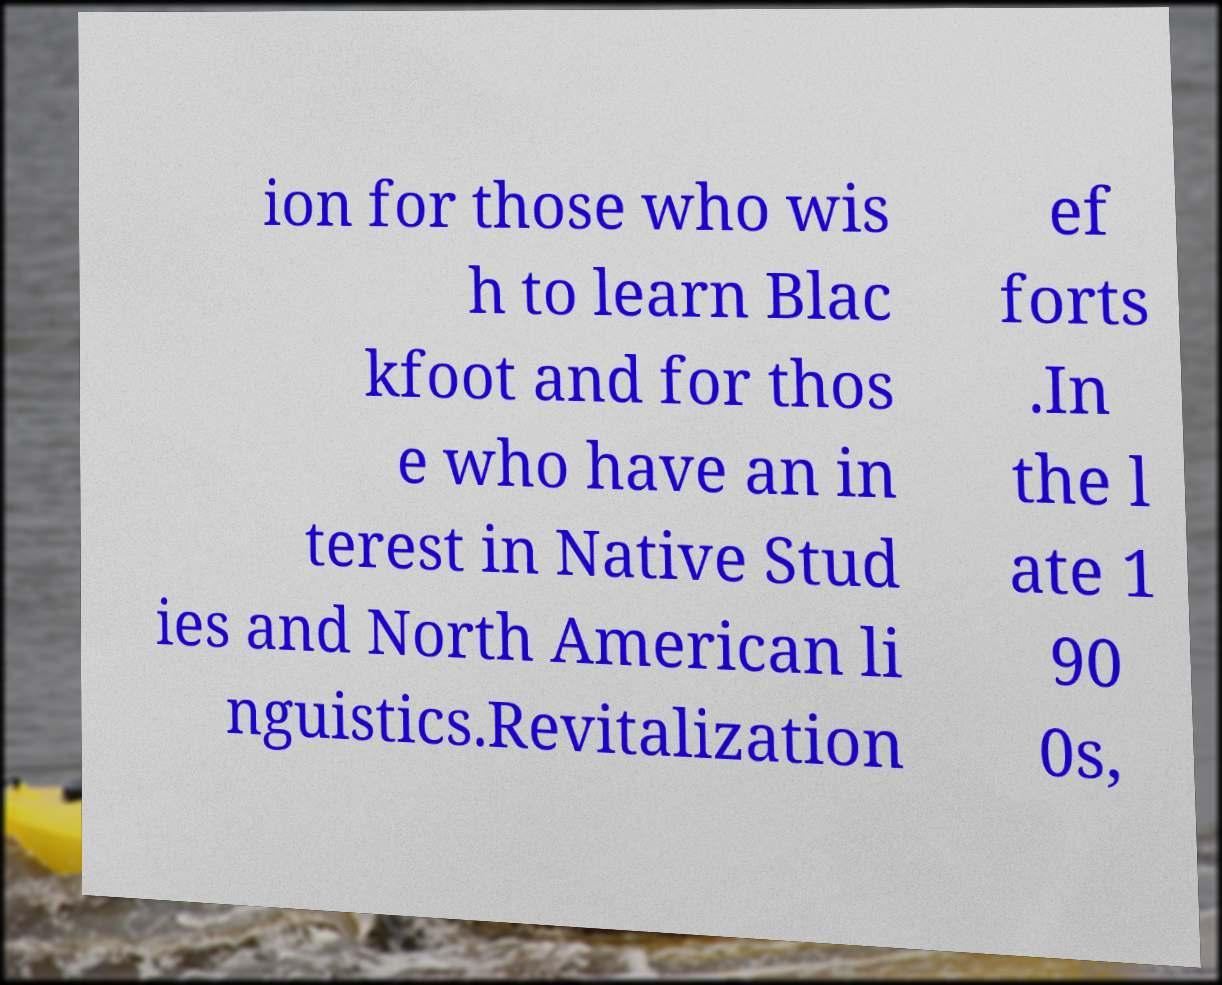Can you accurately transcribe the text from the provided image for me? ion for those who wis h to learn Blac kfoot and for thos e who have an in terest in Native Stud ies and North American li nguistics.Revitalization ef forts .In the l ate 1 90 0s, 